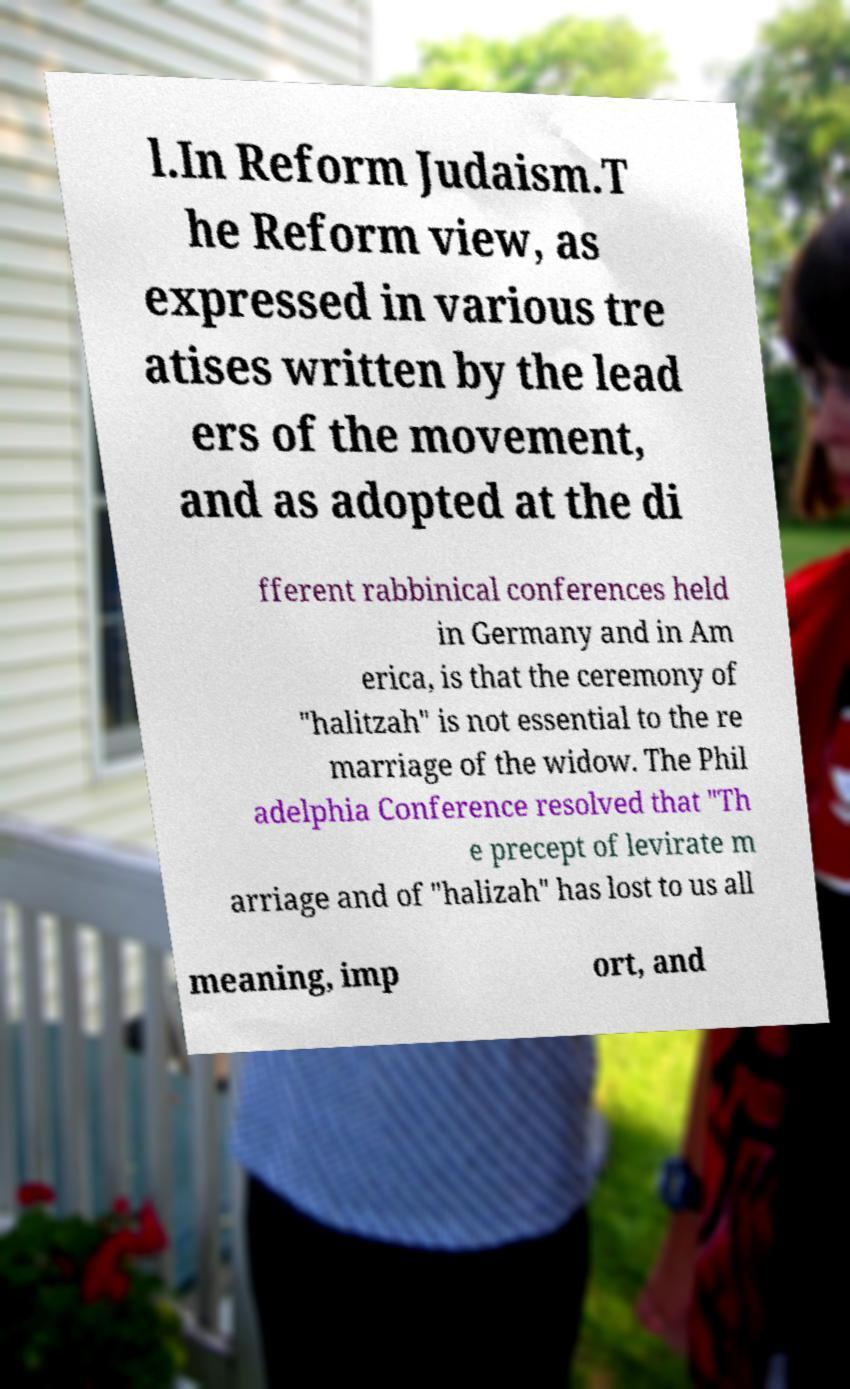Please identify and transcribe the text found in this image. l.In Reform Judaism.T he Reform view, as expressed in various tre atises written by the lead ers of the movement, and as adopted at the di fferent rabbinical conferences held in Germany and in Am erica, is that the ceremony of "halitzah" is not essential to the re marriage of the widow. The Phil adelphia Conference resolved that "Th e precept of levirate m arriage and of "halizah" has lost to us all meaning, imp ort, and 